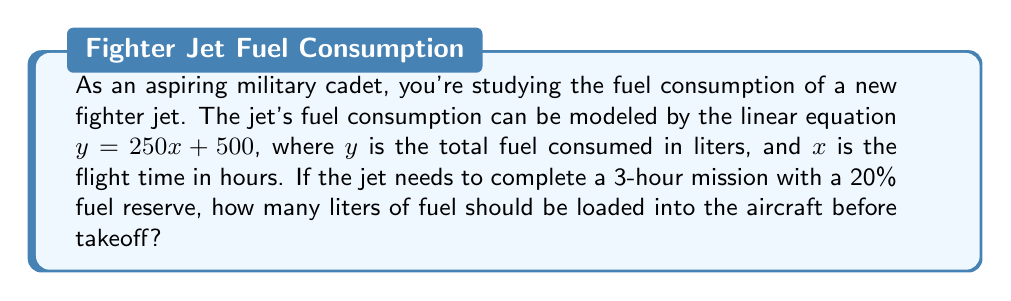What is the answer to this math problem? Let's approach this step-by-step:

1) First, we need to understand what the equation $y = 250x + 500$ represents:
   - $y$ is the total fuel consumed in liters
   - $x$ is the flight time in hours
   - 250 is the rate of fuel consumption per hour
   - 500 is the initial fuel consumption for takeoff

2) We need to calculate the fuel consumption for a 3-hour mission:
   $y = 250(3) + 500$
   $y = 750 + 500 = 1250$ liters

3) Now, we need to add a 20% reserve to this amount:
   20% of 1250 = $1250 * 0.20 = 250$ liters

4) Total fuel required:
   $1250 + 250 = 1500$ liters

Therefore, the aircraft should be loaded with 1500 liters of fuel before takeoff.
Answer: 1500 liters 